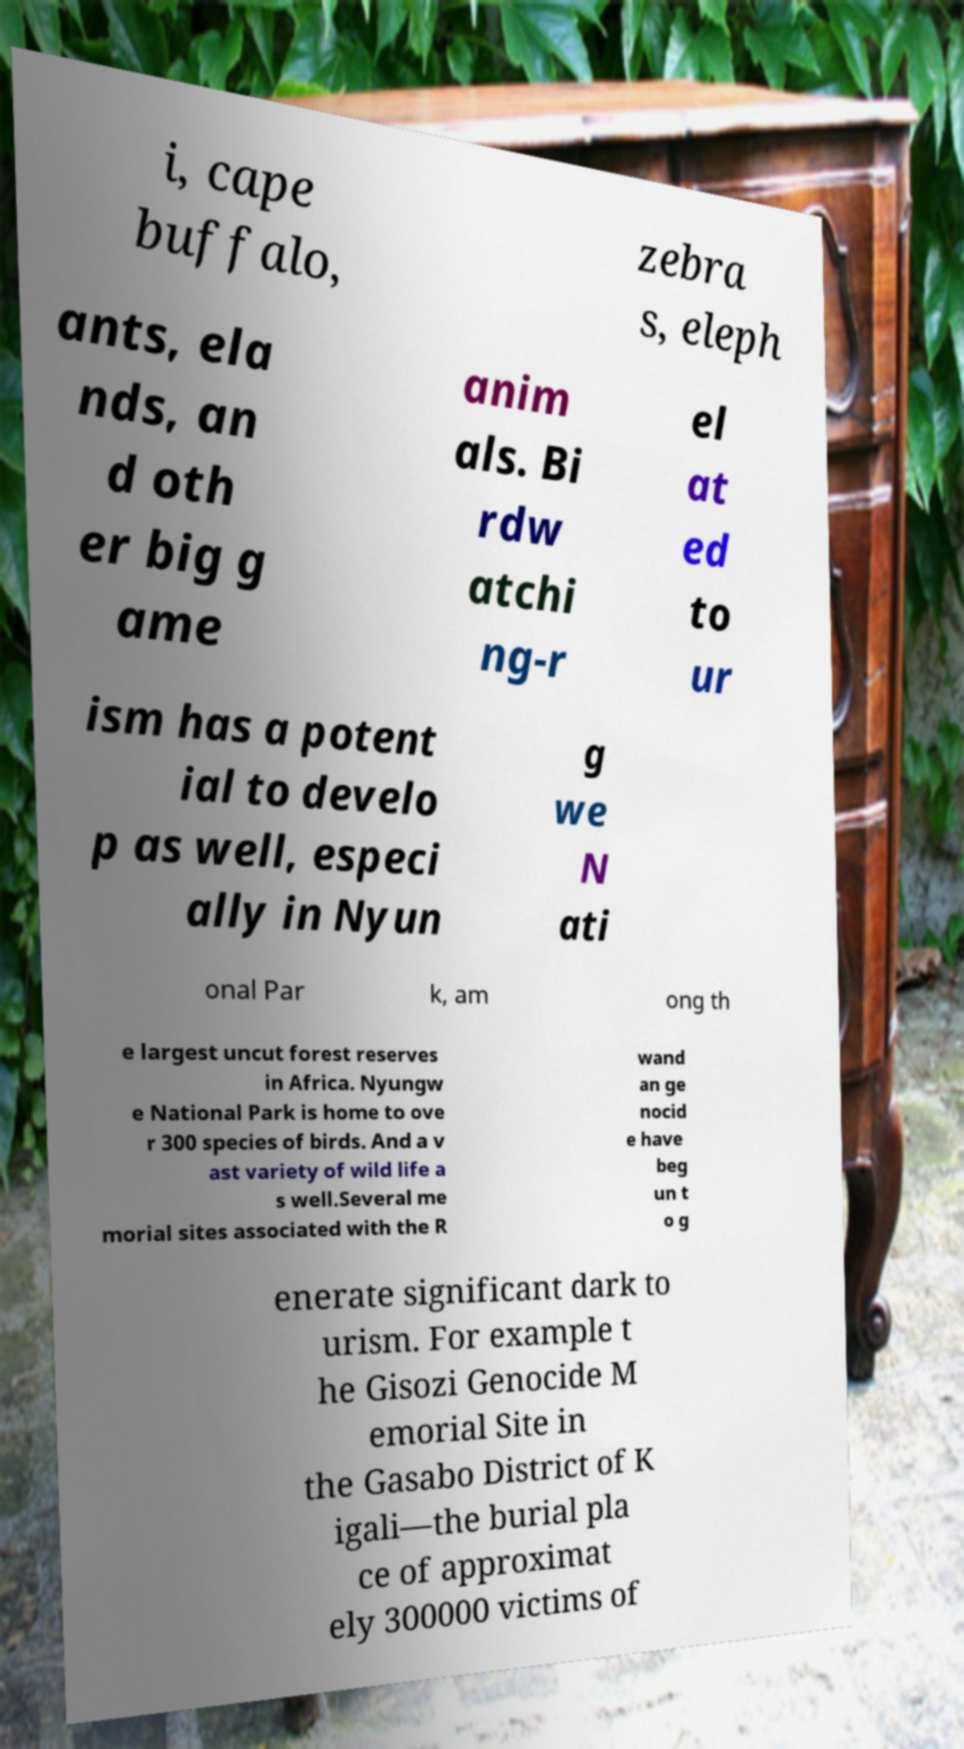There's text embedded in this image that I need extracted. Can you transcribe it verbatim? i, cape buffalo, zebra s, eleph ants, ela nds, an d oth er big g ame anim als. Bi rdw atchi ng-r el at ed to ur ism has a potent ial to develo p as well, especi ally in Nyun g we N ati onal Par k, am ong th e largest uncut forest reserves in Africa. Nyungw e National Park is home to ove r 300 species of birds. And a v ast variety of wild life a s well.Several me morial sites associated with the R wand an ge nocid e have beg un t o g enerate significant dark to urism. For example t he Gisozi Genocide M emorial Site in the Gasabo District of K igali—the burial pla ce of approximat ely 300000 victims of 